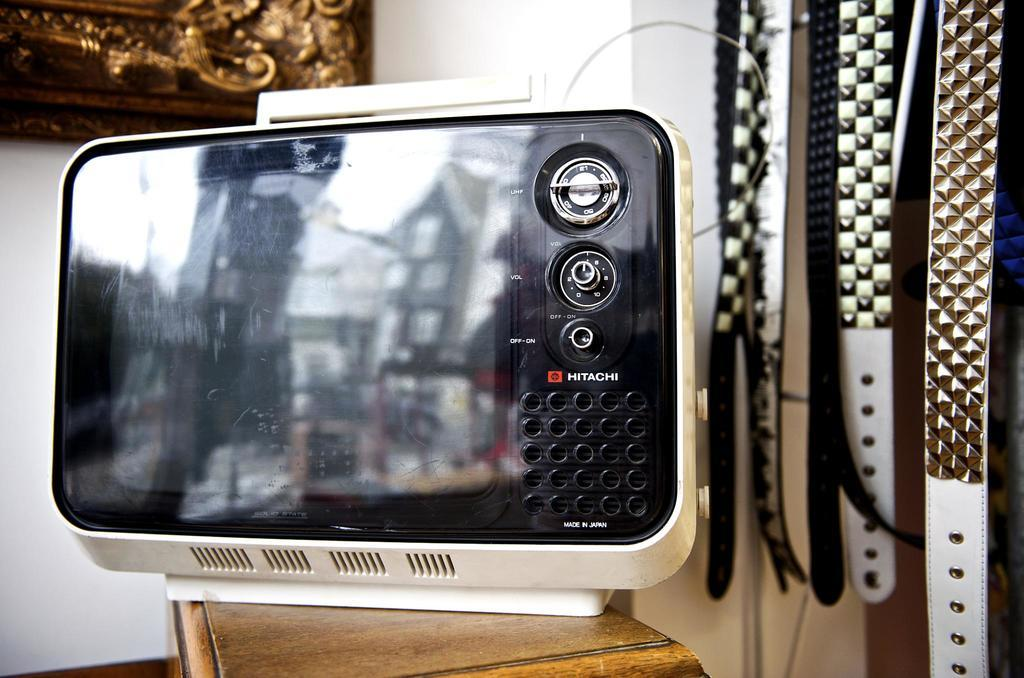<image>
Create a compact narrative representing the image presented. a Hitachi item that is on a brown surface 